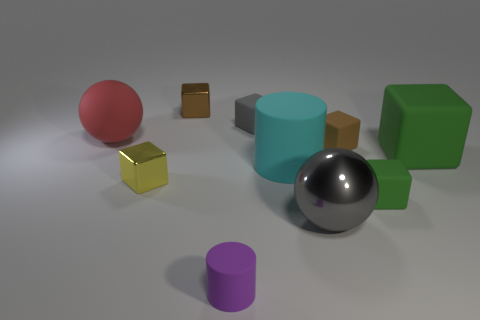How many other objects are there of the same size as the brown shiny thing?
Ensure brevity in your answer.  5. Is there any other thing of the same color as the matte ball?
Keep it short and to the point. No. Are there the same number of tiny brown matte cubes on the left side of the large gray sphere and purple matte cylinders that are behind the purple cylinder?
Provide a succinct answer. Yes. Is the number of small matte objects on the left side of the brown rubber cube greater than the number of gray metal objects?
Ensure brevity in your answer.  Yes. How many things are green objects in front of the yellow metallic block or cyan rubber objects?
Your response must be concise. 2. What number of gray cubes are the same material as the large gray sphere?
Your response must be concise. 0. The rubber thing that is the same color as the big metal sphere is what shape?
Keep it short and to the point. Cube. Are there any tiny purple things of the same shape as the tiny brown metal object?
Offer a terse response. No. What is the shape of the red object that is the same size as the shiny ball?
Provide a succinct answer. Sphere. There is a large metal object; does it have the same color as the rubber cube left of the large gray metal sphere?
Provide a succinct answer. Yes. 